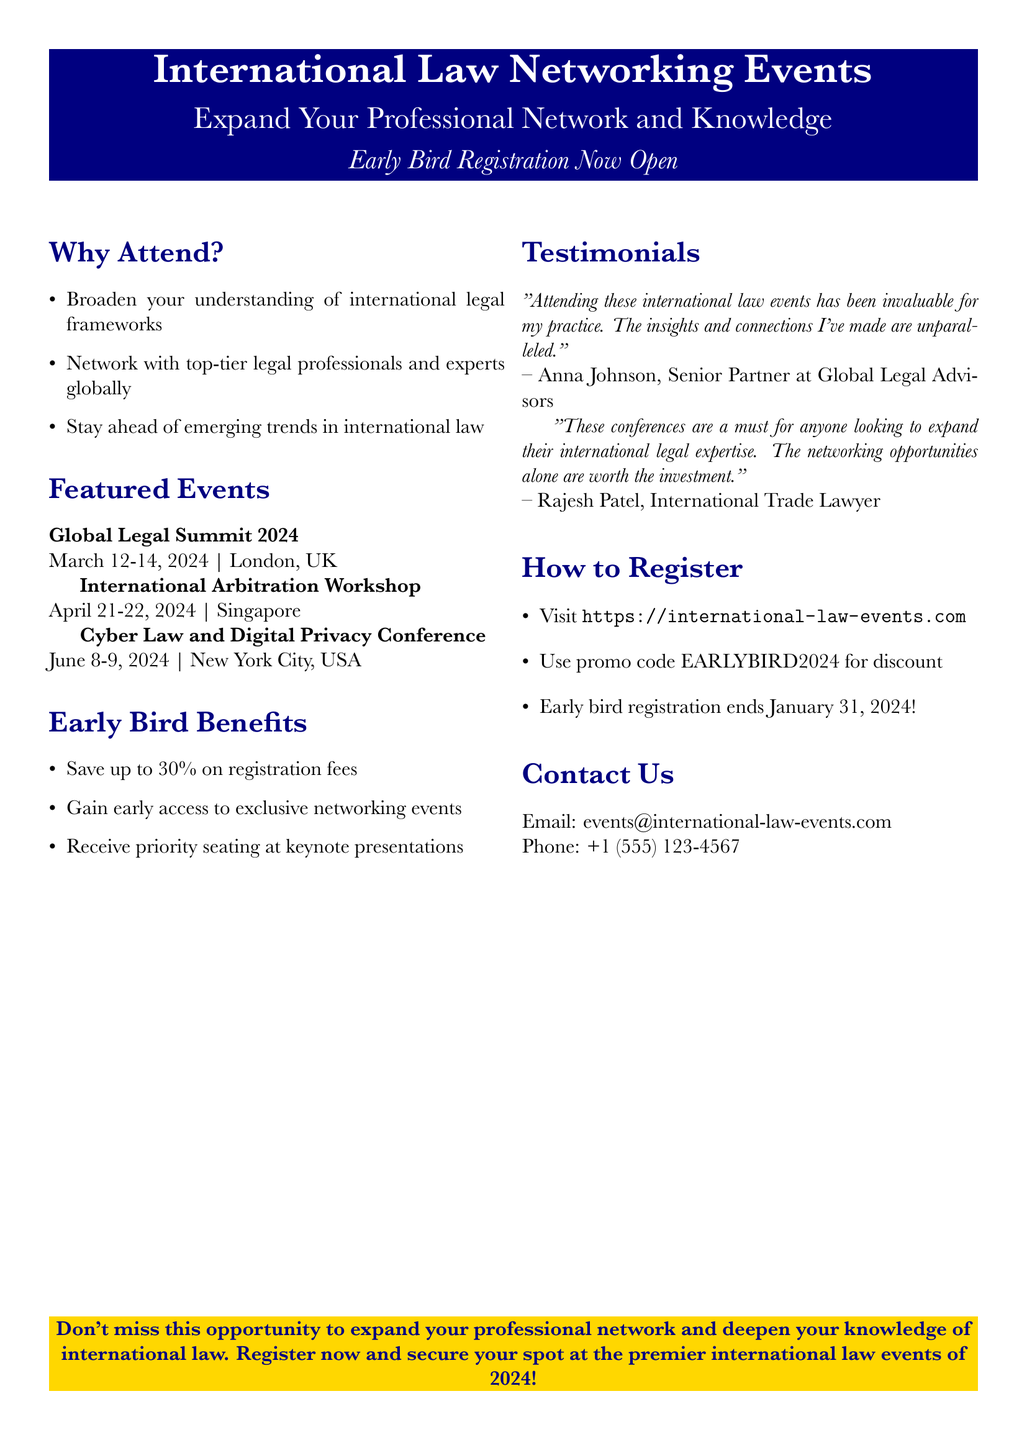What are the dates of the Global Legal Summit 2024? The document lists specific dates for events, including the Global Legal Summit 2024 scheduled for March 12-14, 2024.
Answer: March 12-14, 2024 What is the location of the Cyber Law and Digital Privacy Conference? The document specifies the location for various events, noting that the Cyber Law and Digital Privacy Conference will take place in New York City, USA.
Answer: New York City, USA What percentage can participants save with early bird registration? The document mentions that early bird registration allows participants to save up to 30% on registration fees.
Answer: 30% What is the promo code for early bird registration? The document includes promotional information, stating that the promo code for early bird registration is EARLYBIRD2024.
Answer: EARLYBIRD2024 Who is the testimonial from Anna Johnson? The document includes testimonials from attendees, indicating that Anna Johnson is a Senior Partner at Global Legal Advisors.
Answer: Senior Partner at Global Legal Advisors Which event is scheduled for April 21-22, 2024? The document specifies the dates and events, noting that the International Arbitration Workshop is scheduled for April 21-22, 2024.
Answer: International Arbitration Workshop When does early bird registration end? The document specifies the cutoff date for early bird registration as January 31, 2024.
Answer: January 31, 2024 What email address can be used to contact the event organizers? The document provides contact information, including the email address for inquiries as events@international-law-events.com.
Answer: events@international-law-events.com 